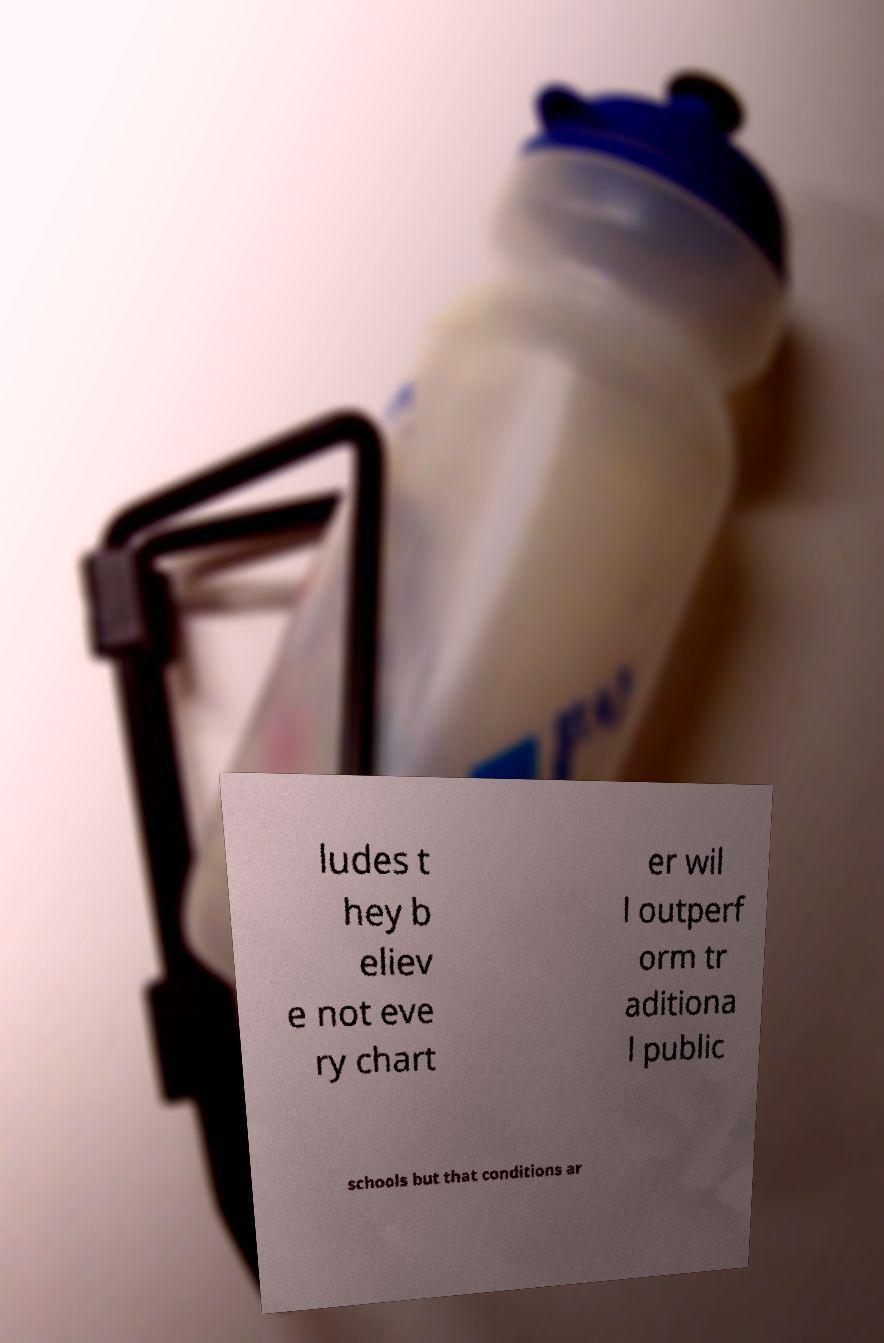Can you read and provide the text displayed in the image?This photo seems to have some interesting text. Can you extract and type it out for me? ludes t hey b eliev e not eve ry chart er wil l outperf orm tr aditiona l public schools but that conditions ar 